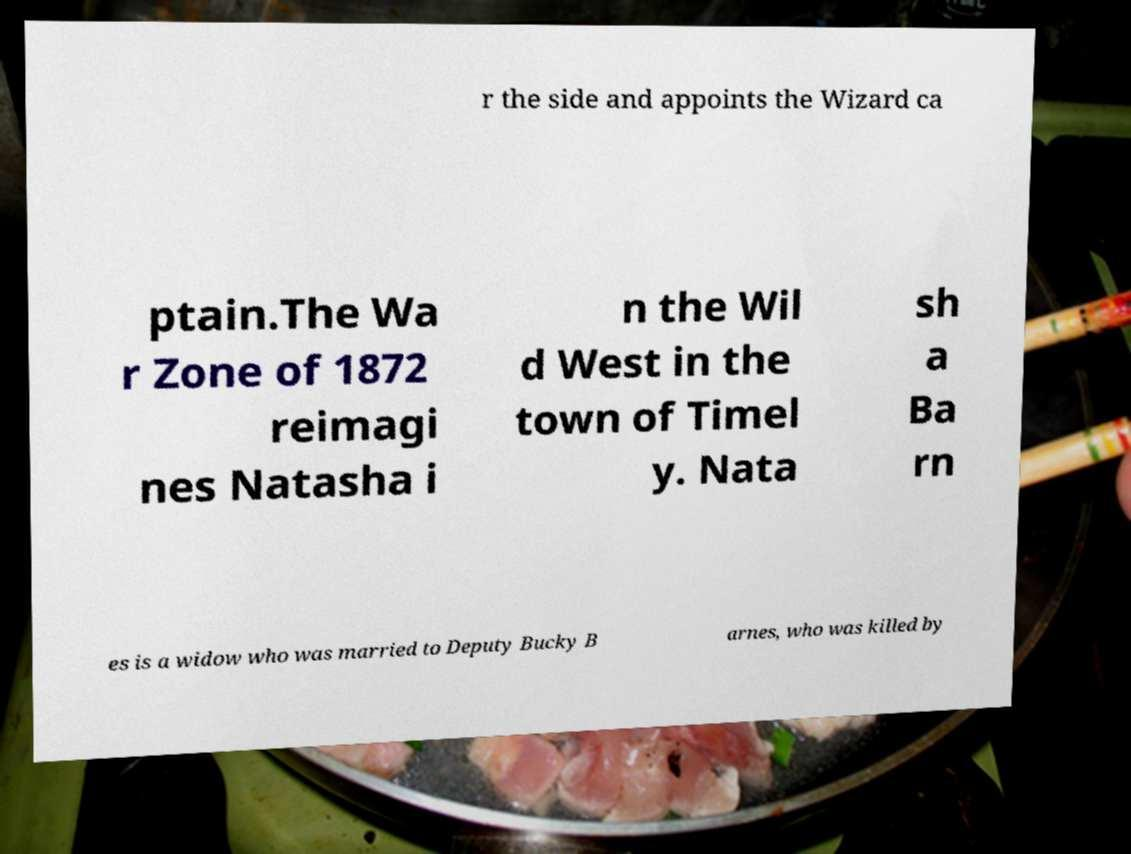What messages or text are displayed in this image? I need them in a readable, typed format. r the side and appoints the Wizard ca ptain.The Wa r Zone of 1872 reimagi nes Natasha i n the Wil d West in the town of Timel y. Nata sh a Ba rn es is a widow who was married to Deputy Bucky B arnes, who was killed by 